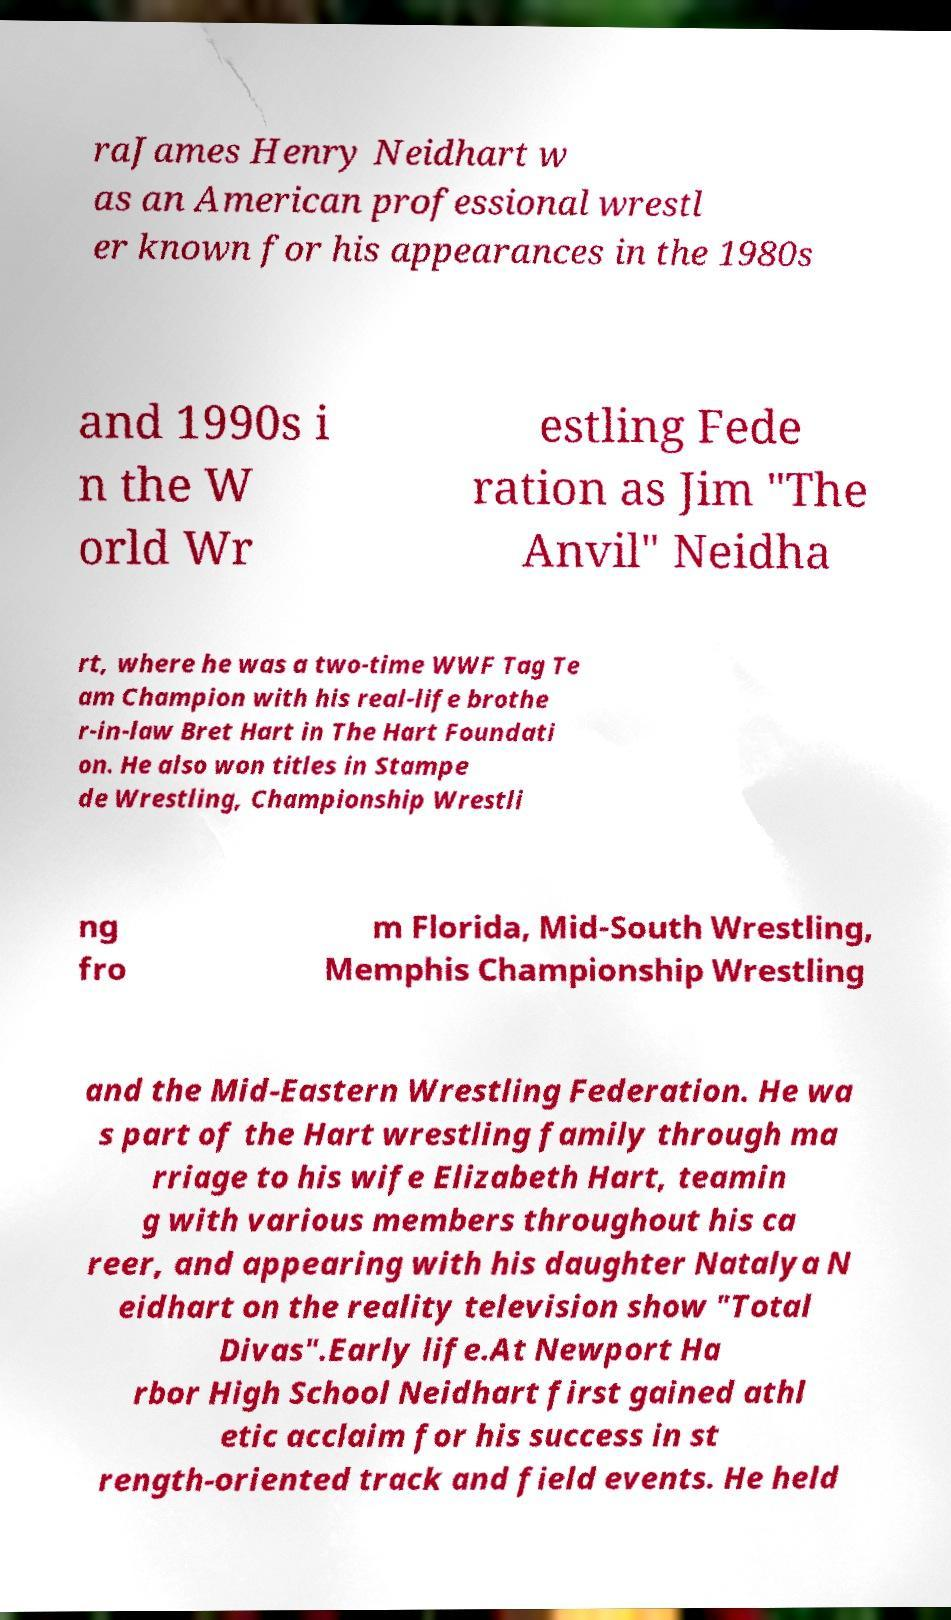For documentation purposes, I need the text within this image transcribed. Could you provide that? raJames Henry Neidhart w as an American professional wrestl er known for his appearances in the 1980s and 1990s i n the W orld Wr estling Fede ration as Jim "The Anvil" Neidha rt, where he was a two-time WWF Tag Te am Champion with his real-life brothe r-in-law Bret Hart in The Hart Foundati on. He also won titles in Stampe de Wrestling, Championship Wrestli ng fro m Florida, Mid-South Wrestling, Memphis Championship Wrestling and the Mid-Eastern Wrestling Federation. He wa s part of the Hart wrestling family through ma rriage to his wife Elizabeth Hart, teamin g with various members throughout his ca reer, and appearing with his daughter Natalya N eidhart on the reality television show "Total Divas".Early life.At Newport Ha rbor High School Neidhart first gained athl etic acclaim for his success in st rength-oriented track and field events. He held 